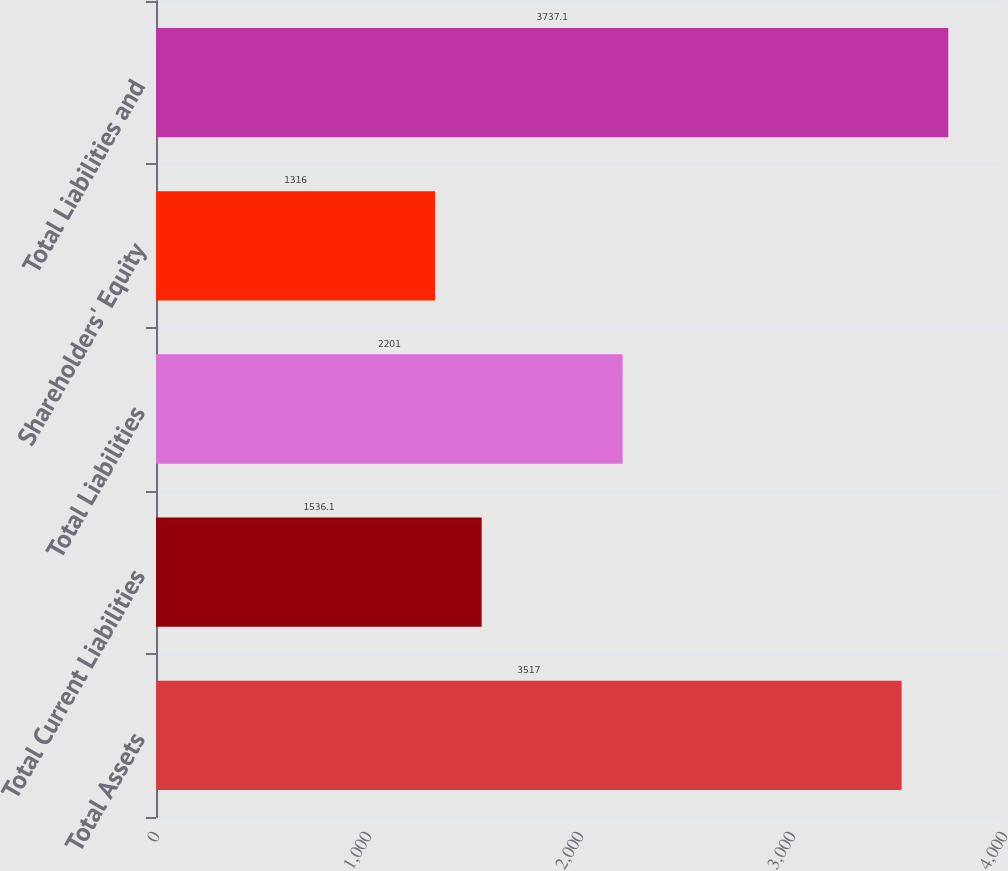<chart> <loc_0><loc_0><loc_500><loc_500><bar_chart><fcel>Total Assets<fcel>Total Current Liabilities<fcel>Total Liabilities<fcel>Shareholders' Equity<fcel>Total Liabilities and<nl><fcel>3517<fcel>1536.1<fcel>2201<fcel>1316<fcel>3737.1<nl></chart> 